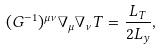Convert formula to latex. <formula><loc_0><loc_0><loc_500><loc_500>( G ^ { - 1 } ) ^ { \mu \nu } \nabla _ { \mu } \nabla _ { \nu } T = \frac { L _ { T } } { 2 L _ { y } } ,</formula> 